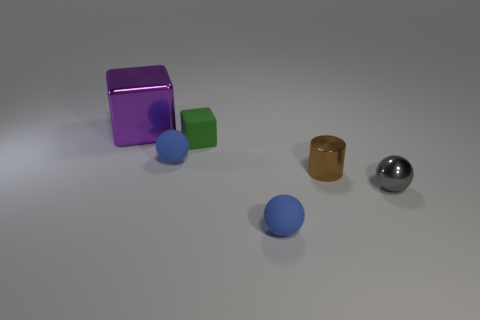Subtract all shiny balls. How many balls are left? 2 Add 3 small balls. How many objects exist? 9 Subtract all blue balls. How many balls are left? 1 Subtract all big objects. Subtract all matte cubes. How many objects are left? 4 Add 2 gray shiny things. How many gray shiny things are left? 3 Add 1 purple cubes. How many purple cubes exist? 2 Subtract 0 gray blocks. How many objects are left? 6 Subtract all blocks. How many objects are left? 4 Subtract 1 cylinders. How many cylinders are left? 0 Subtract all yellow cubes. Subtract all cyan balls. How many cubes are left? 2 